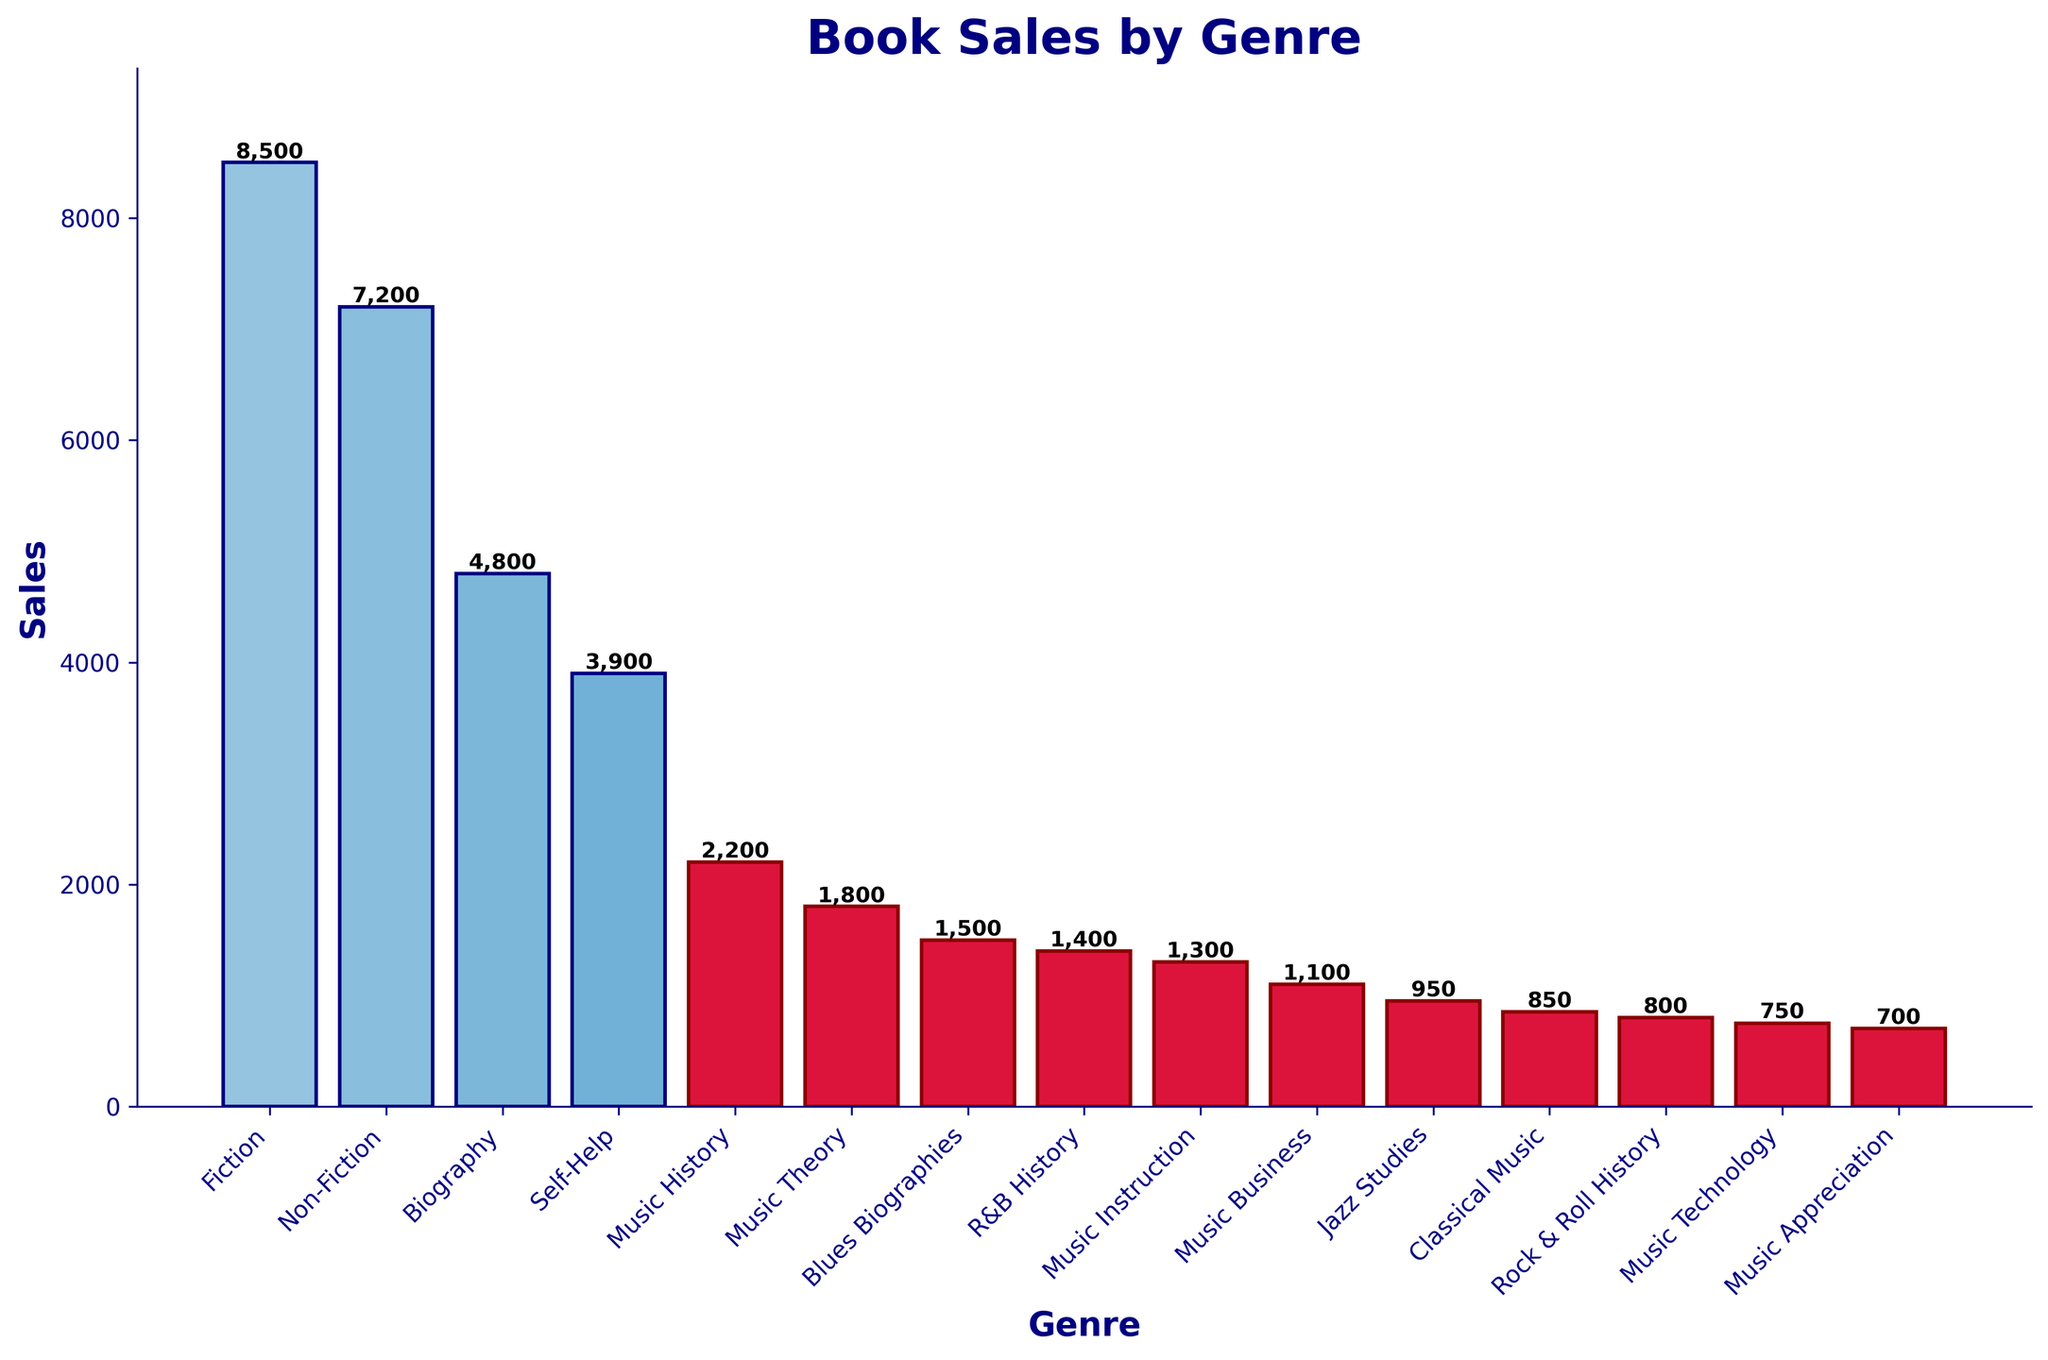What genre has the lowest book sales after all the music-related categories are considered? Exclude all the music-related categories and then find the bar with the lowest height among the remaining genres. The genre with 3900 sales in Self-Help is lower than all other non-music genres.
Answer: Self-Help What is the combined sales of 'Blues Biographies' and 'R&B History' books? Look at the heights of the bars for 'Blues Biographies' and 'R&B History'. The sales are 1500 and 1400 respectively. The combined sales are 1500 + 1400 = 2900.
Answer: 2900 How much higher are Fiction sales compared to Non-Fiction sales? Identify the heights of the Fiction and Non-Fiction bars. Fiction sales are 8500 and Non-Fiction sales are 7200. The difference is 8500 - 7200 = 1300.
Answer: 1300 Which genre has the most sales among the music-related categories? Among the music-related categories, identify the highest bar. 'Music History' with 2200 sales is the highest.
Answer: Music History What is the average sales value of all genres together? Sum the sales of all the genres and then divide by the number of genres. The total sales are 8500 + 7200 + 4800 + 3900 + 2200 + 1800 + 1500 + 1400 + 1300 + 1100 + 950 + 850 + 800 + 750 + 700 = 42150. There are 15 genres. The average sales are 42150 / 15 ≈ 2810.
Answer: 2810 